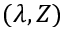Convert formula to latex. <formula><loc_0><loc_0><loc_500><loc_500>( \lambda , Z )</formula> 